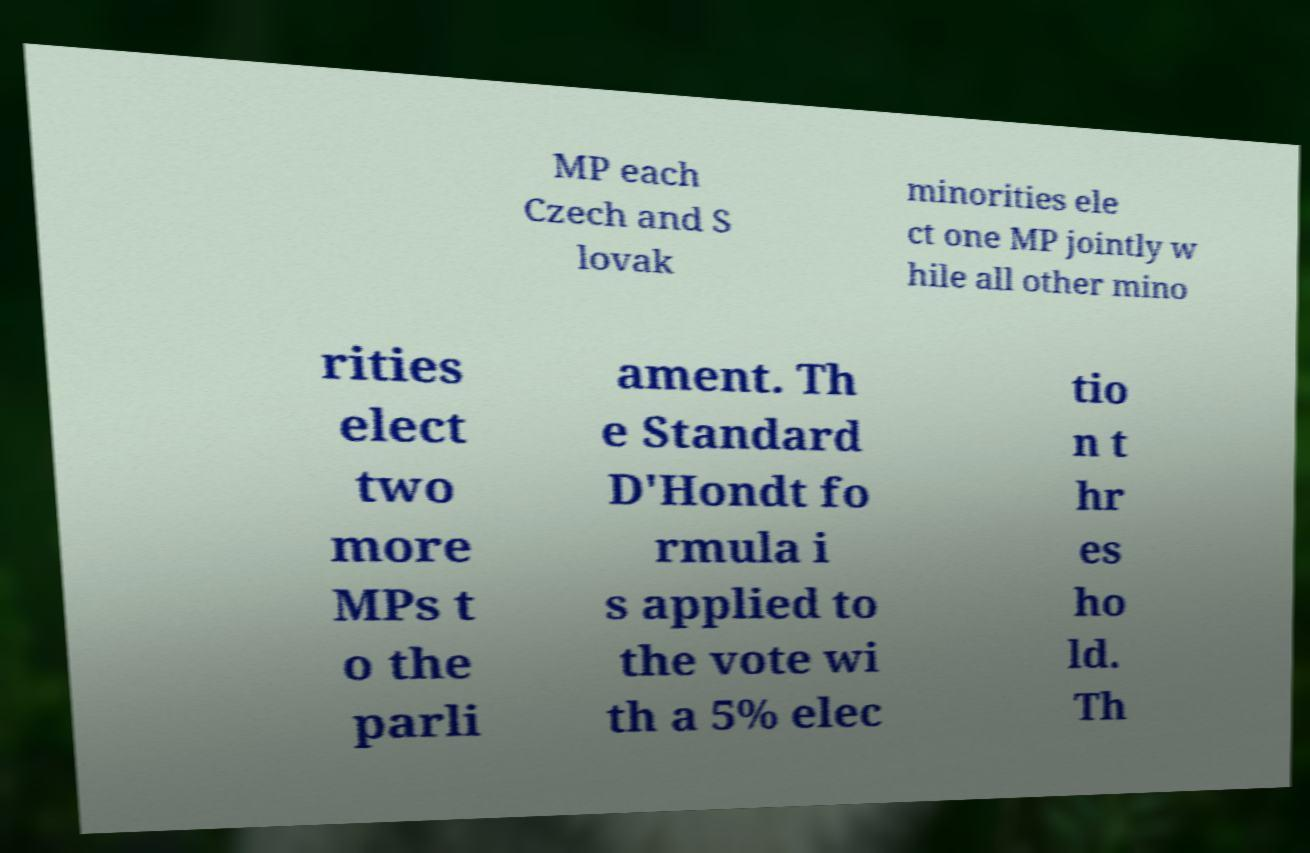Could you extract and type out the text from this image? MP each Czech and S lovak minorities ele ct one MP jointly w hile all other mino rities elect two more MPs t o the parli ament. Th e Standard D'Hondt fo rmula i s applied to the vote wi th a 5% elec tio n t hr es ho ld. Th 